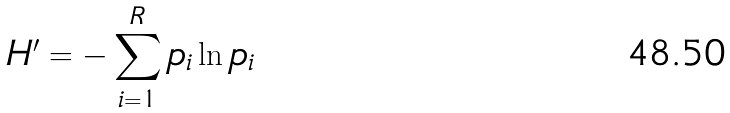Convert formula to latex. <formula><loc_0><loc_0><loc_500><loc_500>H ^ { \prime } = - \sum _ { i = 1 } ^ { R } p _ { i } \ln p _ { i }</formula> 